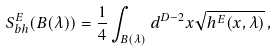Convert formula to latex. <formula><loc_0><loc_0><loc_500><loc_500>S _ { b h } ^ { E } ( B ( \lambda ) ) = \frac { 1 } { 4 } \int _ { B ( \lambda ) } d ^ { D - 2 } x \sqrt { h ^ { E } ( x , \lambda ) } \, ,</formula> 